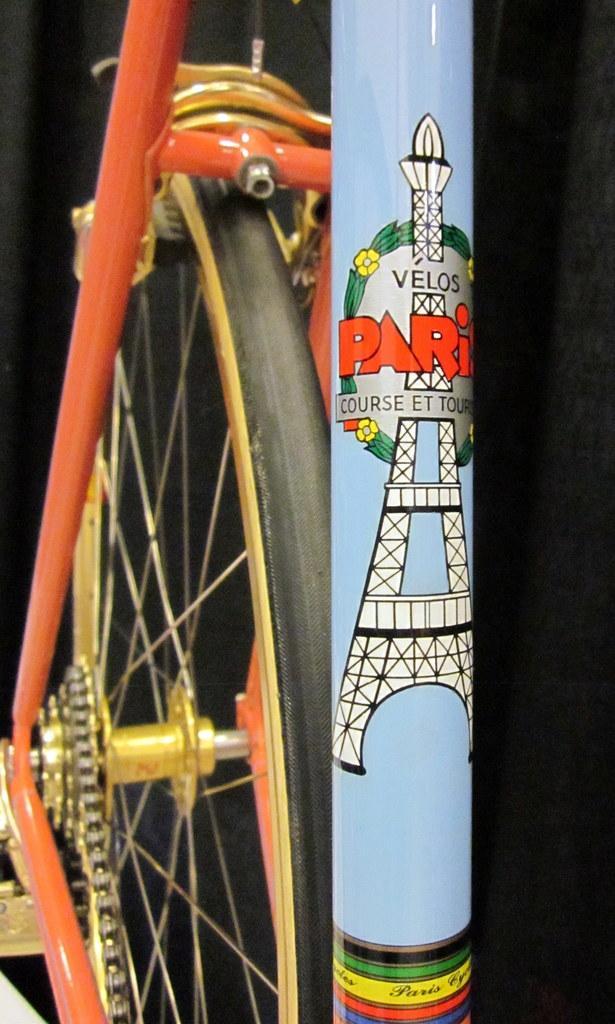Please provide a concise description of this image. In the center of the image we can see a wheel, rods, chain and pole. In the background the image is dark. 